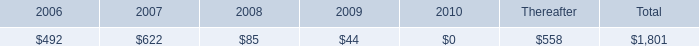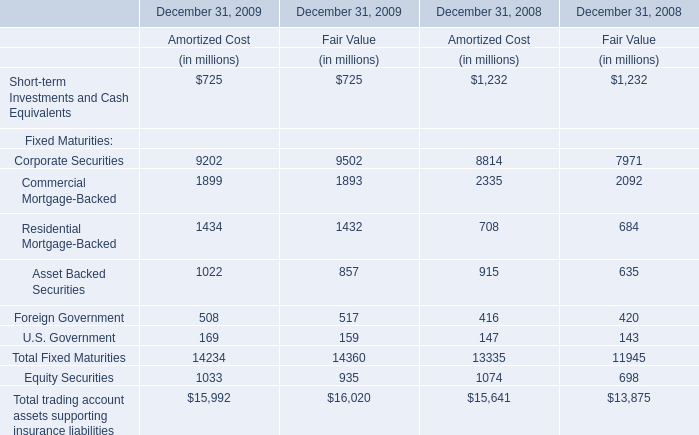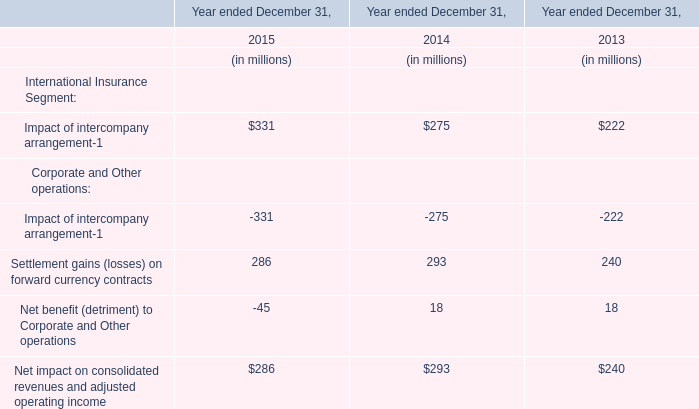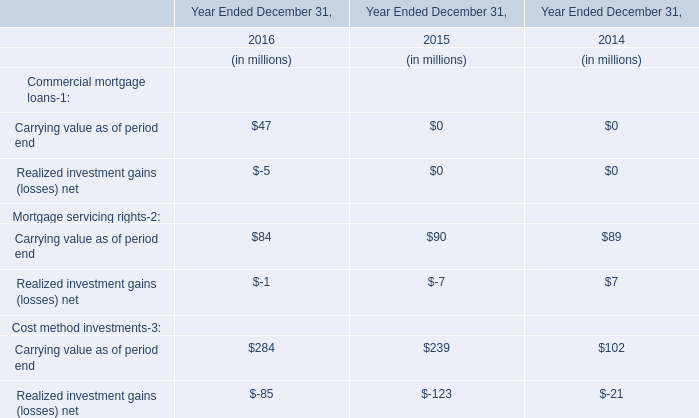The Fair Value on December 31 for Equity Securities in which year is higher? 
Answer: 2009. 